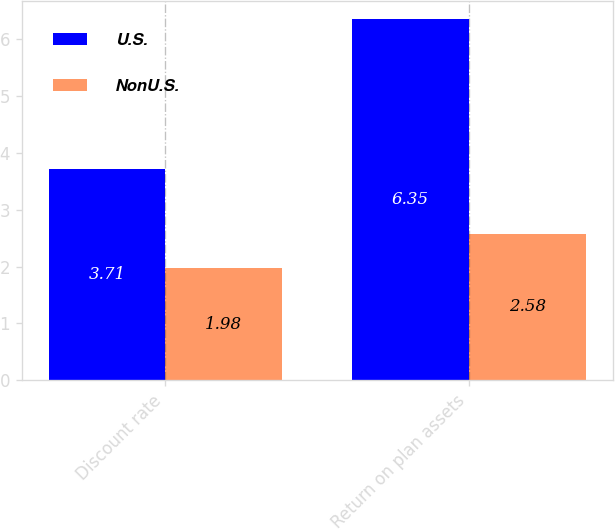Convert chart. <chart><loc_0><loc_0><loc_500><loc_500><stacked_bar_chart><ecel><fcel>Discount rate<fcel>Return on plan assets<nl><fcel>U.S.<fcel>3.71<fcel>6.35<nl><fcel>NonU.S.<fcel>1.98<fcel>2.58<nl></chart> 